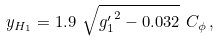Convert formula to latex. <formula><loc_0><loc_0><loc_500><loc_500>y _ { H _ { 1 } } = 1 . 9 \ \sqrt { { g ^ { \prime } _ { 1 } } ^ { 2 } - 0 . 0 3 2 } \ C _ { \phi } \, ,</formula> 